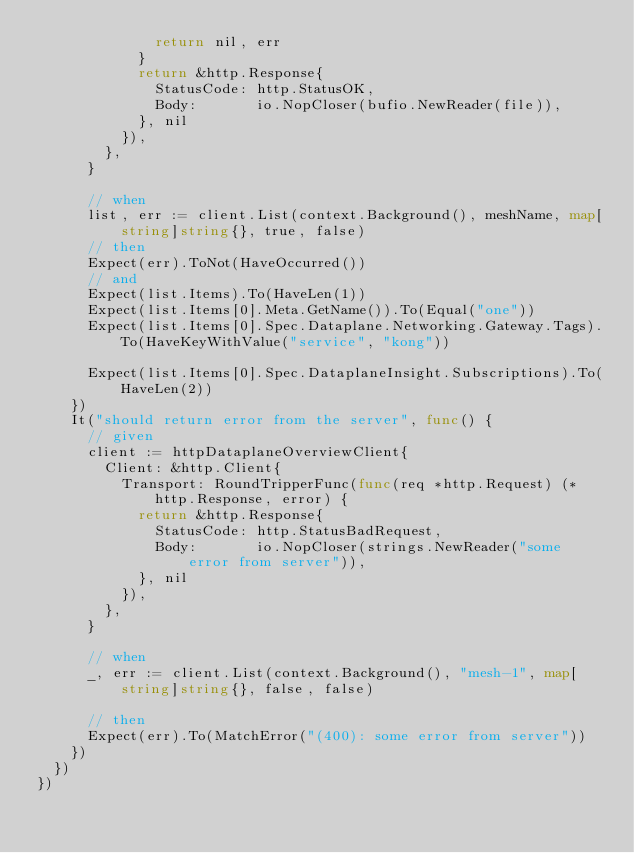<code> <loc_0><loc_0><loc_500><loc_500><_Go_>							return nil, err
						}
						return &http.Response{
							StatusCode: http.StatusOK,
							Body:       io.NopCloser(bufio.NewReader(file)),
						}, nil
					}),
				},
			}

			// when
			list, err := client.List(context.Background(), meshName, map[string]string{}, true, false)
			// then
			Expect(err).ToNot(HaveOccurred())
			// and
			Expect(list.Items).To(HaveLen(1))
			Expect(list.Items[0].Meta.GetName()).To(Equal("one"))
			Expect(list.Items[0].Spec.Dataplane.Networking.Gateway.Tags).To(HaveKeyWithValue("service", "kong"))

			Expect(list.Items[0].Spec.DataplaneInsight.Subscriptions).To(HaveLen(2))
		})
		It("should return error from the server", func() {
			// given
			client := httpDataplaneOverviewClient{
				Client: &http.Client{
					Transport: RoundTripperFunc(func(req *http.Request) (*http.Response, error) {
						return &http.Response{
							StatusCode: http.StatusBadRequest,
							Body:       io.NopCloser(strings.NewReader("some error from server")),
						}, nil
					}),
				},
			}

			// when
			_, err := client.List(context.Background(), "mesh-1", map[string]string{}, false, false)

			// then
			Expect(err).To(MatchError("(400): some error from server"))
		})
	})
})
</code> 